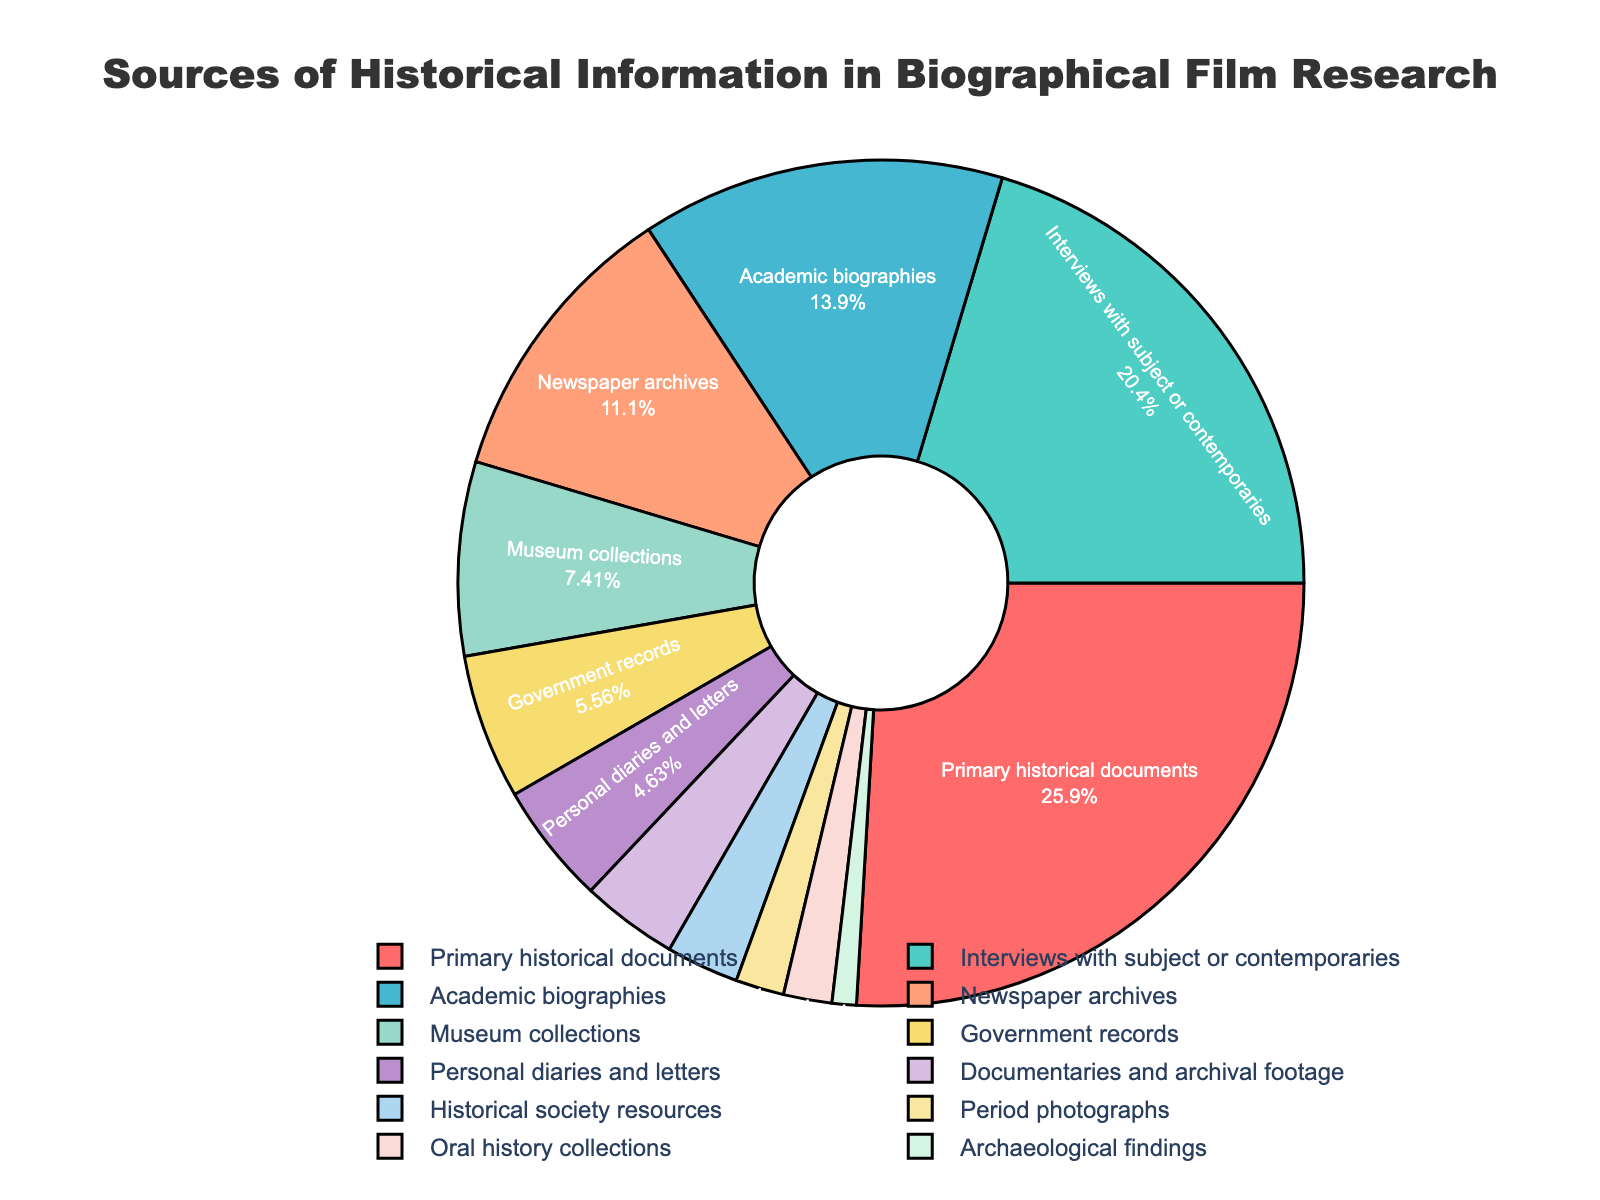what is the largest source of historical information used in biographical film research? The largest source can be identified by looking at the segment with the highest percentage. "Primary historical documents" have the highest percentage at 28%.
Answer: Primary historical documents what is the sum of the percentages for "Interviews with subject or contemporaries" and "Academic biographies"? To find the sum, add the percentages of "Interviews with subject or contemporaries" (22%) and "Academic biographies" (15%). Therefore, 22 + 15 = 37%.
Answer: 37% which source has a smaller percentage, "Newspaper archives" or "Government records"? Directly compare the percentages of "Newspaper archives" (12%) and "Government records" (6%). Since 6% is less than 12%, "Government records" has a smaller percentage.
Answer: Government records which sources make up less than 4% of the total? Analyze the segments and identify the sources with percentages less than 4%. These include "Documentaries and archival footage" (4%), "Historical society resources" (3%), "Period photographs" (2%), "Oral history collections" (2%), and "Archaeological findings" (1%).
Answer: Documentaries and archival footage, Historical society resources, Period photographs, Oral history collections, Archaeological findings what is the most visually prominent segment in terms of color? The most visually prominent segment can be determined by the most visually striking color. The "Primary historical documents" segment is dark red and seems to attract the eye the most.
Answer: Primary historical documents what is the total percentage of sources related to visual materials (e.g., "Period photographs" and "Documentaries and archival footage")? Add the percentages of "Period photographs" (2%) and "Documentaries and archival footage" (4%). Therefore, 2 + 4 = 6%.
Answer: 6% how does the percentage of "Interviews with subject or contemporaries" compare to "Primary historical documents"? Compare the percentages of "Interviews with subject or contemporaries" (22%) and "Primary historical documents" (28%). Since 22% is less than 28%, "Primary historical documents" has a higher percentage.
Answer: Primary historical documents have a higher percentage which source has the second lowest percentage and what is it? The second lowest percentage is higher than the lowest (1%). Identify "Period photographs" and "Oral history collections" both at 2%.
Answer: Period photographs or Oral history collections, 2% what is the combined percentage of "Personal diaries and letters" and "Museum collections"? Add the percentages of "Personal diaries and letters" (5%) and "Museum collections" (8%). Therefore, 5 + 8 = 13%.
Answer: 13% what is the difference in percentage between "Academic biographies" and "Government records"? Subtract the percentage of "Government records" (6%) from "Academic biographies" (15%). Therefore, 15 - 6 = 9%.
Answer: 9% 